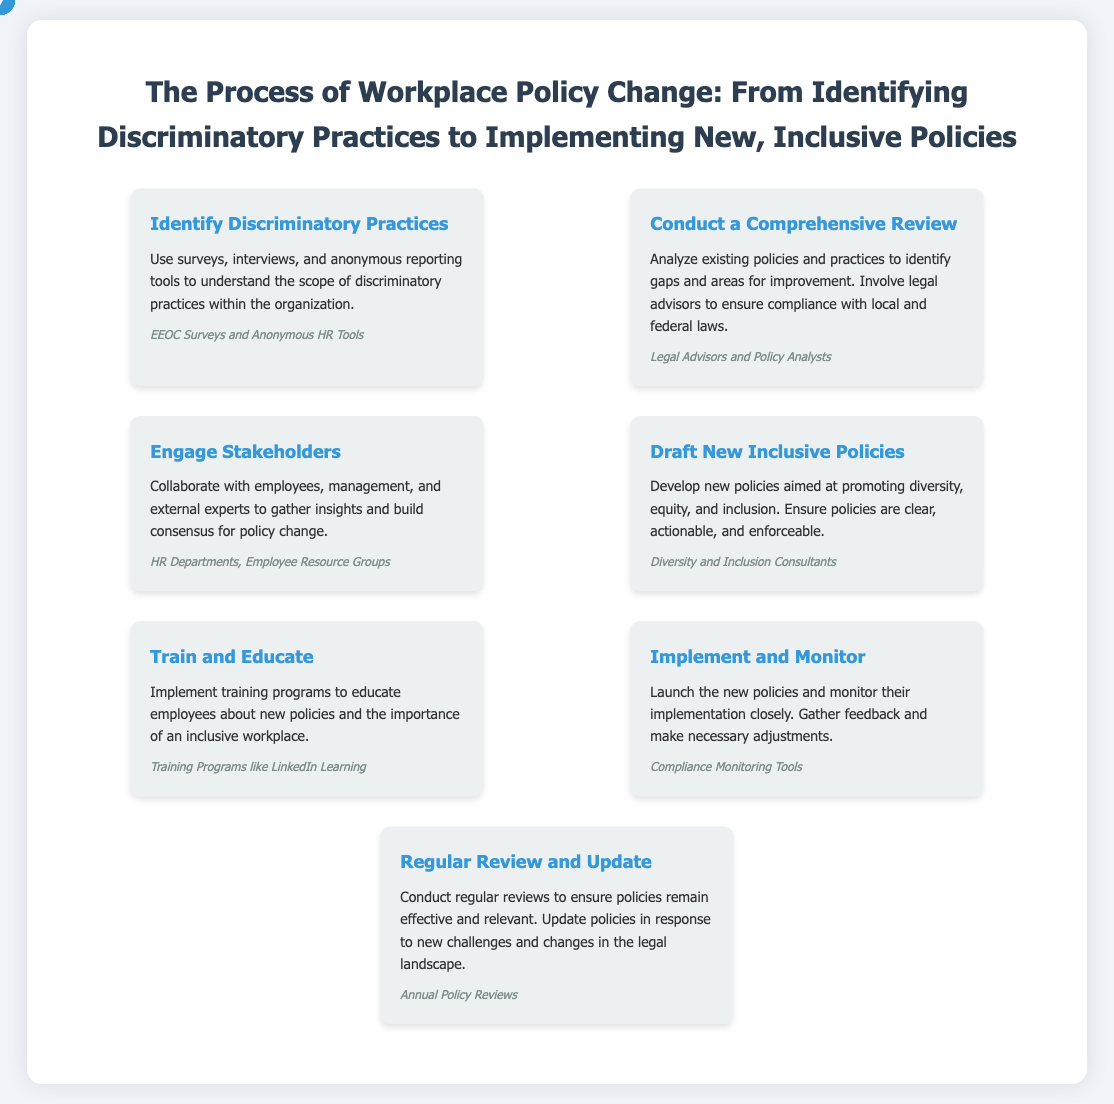What is the first step in the process? The first step identified in the process is to "Identify Discriminatory Practices."
Answer: Identify Discriminatory Practices Who is involved in conducting a comprehensive review? The document mentions "Legal Advisors and Policy Analysts" as those involved in the comprehensive review.
Answer: Legal Advisors and Policy Analysts What type of consultants are needed to draft new policies? The step identifies the need for "Diversity and Inclusion Consultants" in drafting new policies.
Answer: Diversity and Inclusion Consultants How many steps are there in the process? The document outlines a total of seven steps in the workplace policy change process.
Answer: Seven What is the focus of the training programs mentioned? The training programs aim to educate employees about "new policies and the importance of an inclusive workplace."
Answer: New policies and the importance of an inclusive workplace Which tools are suggested for monitoring compliance? The document suggests "Compliance Monitoring Tools" for monitoring the implementation of new policies.
Answer: Compliance Monitoring Tools How often should policies be reviewed according to the document? The process recommends conducting "regular reviews" of policies to ensure effectiveness.
Answer: Regular reviews What is the main outcome intended from engaging stakeholders? The primary goal of engaging stakeholders is to "gather insights and build consensus for policy change."
Answer: Gather insights and build consensus for policy change 